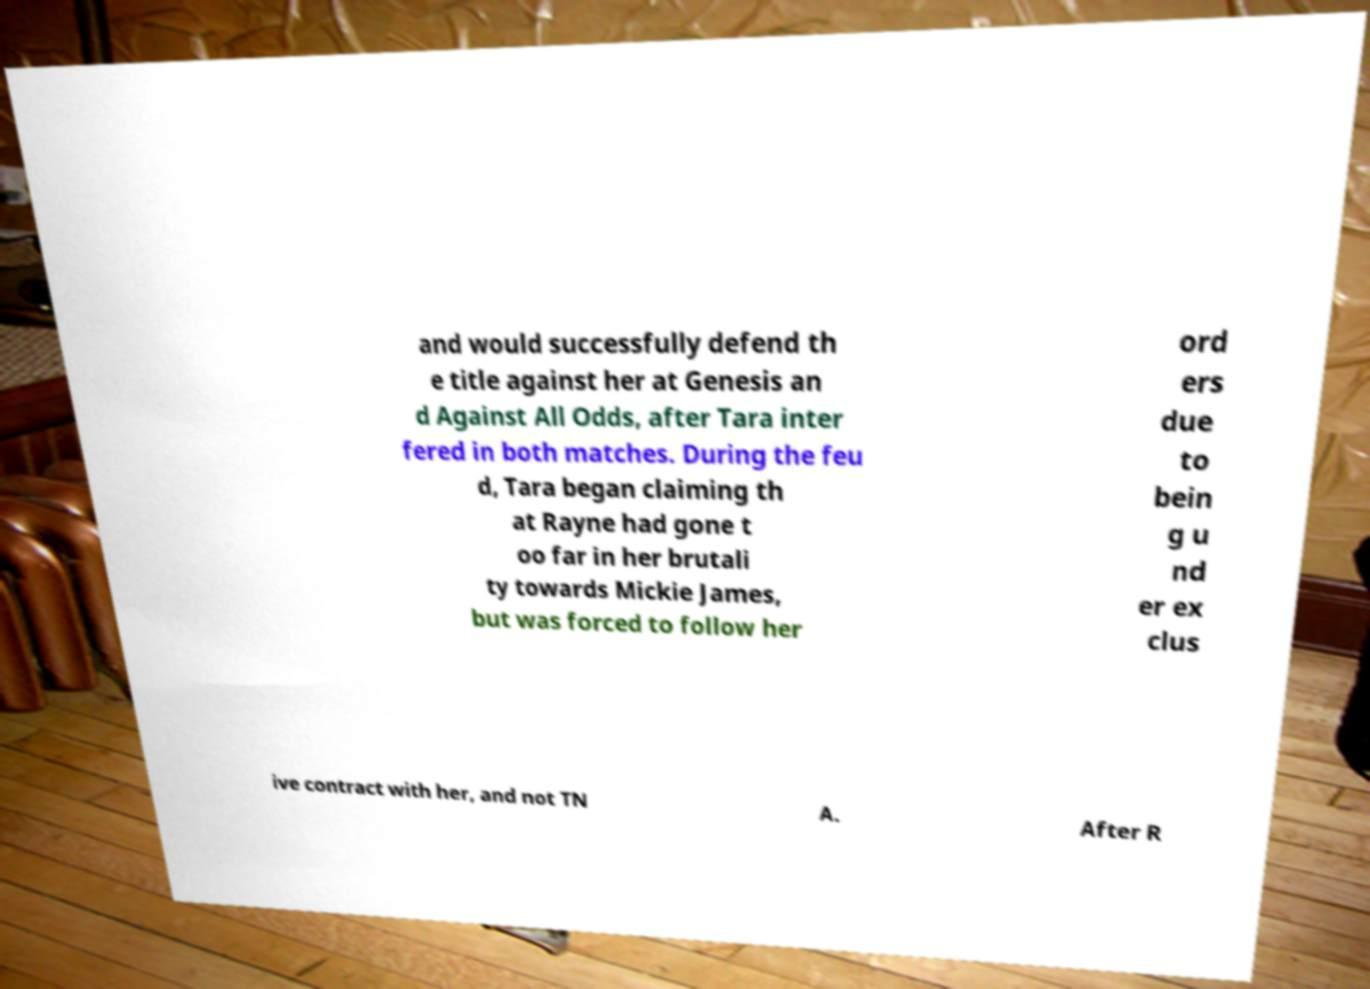Can you read and provide the text displayed in the image?This photo seems to have some interesting text. Can you extract and type it out for me? and would successfully defend th e title against her at Genesis an d Against All Odds, after Tara inter fered in both matches. During the feu d, Tara began claiming th at Rayne had gone t oo far in her brutali ty towards Mickie James, but was forced to follow her ord ers due to bein g u nd er ex clus ive contract with her, and not TN A. After R 